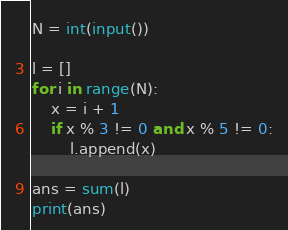Convert code to text. <code><loc_0><loc_0><loc_500><loc_500><_Python_>N = int(input())

l = []
for i in range(N):
    x = i + 1
    if x % 3 != 0 and x % 5 != 0:
        l.append(x)

ans = sum(l)
print(ans)</code> 